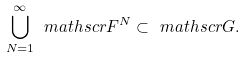<formula> <loc_0><loc_0><loc_500><loc_500>\bigcup _ { N = 1 } ^ { \infty } \ m a t h s c r F ^ { N } \subset \ m a t h s c r G .</formula> 